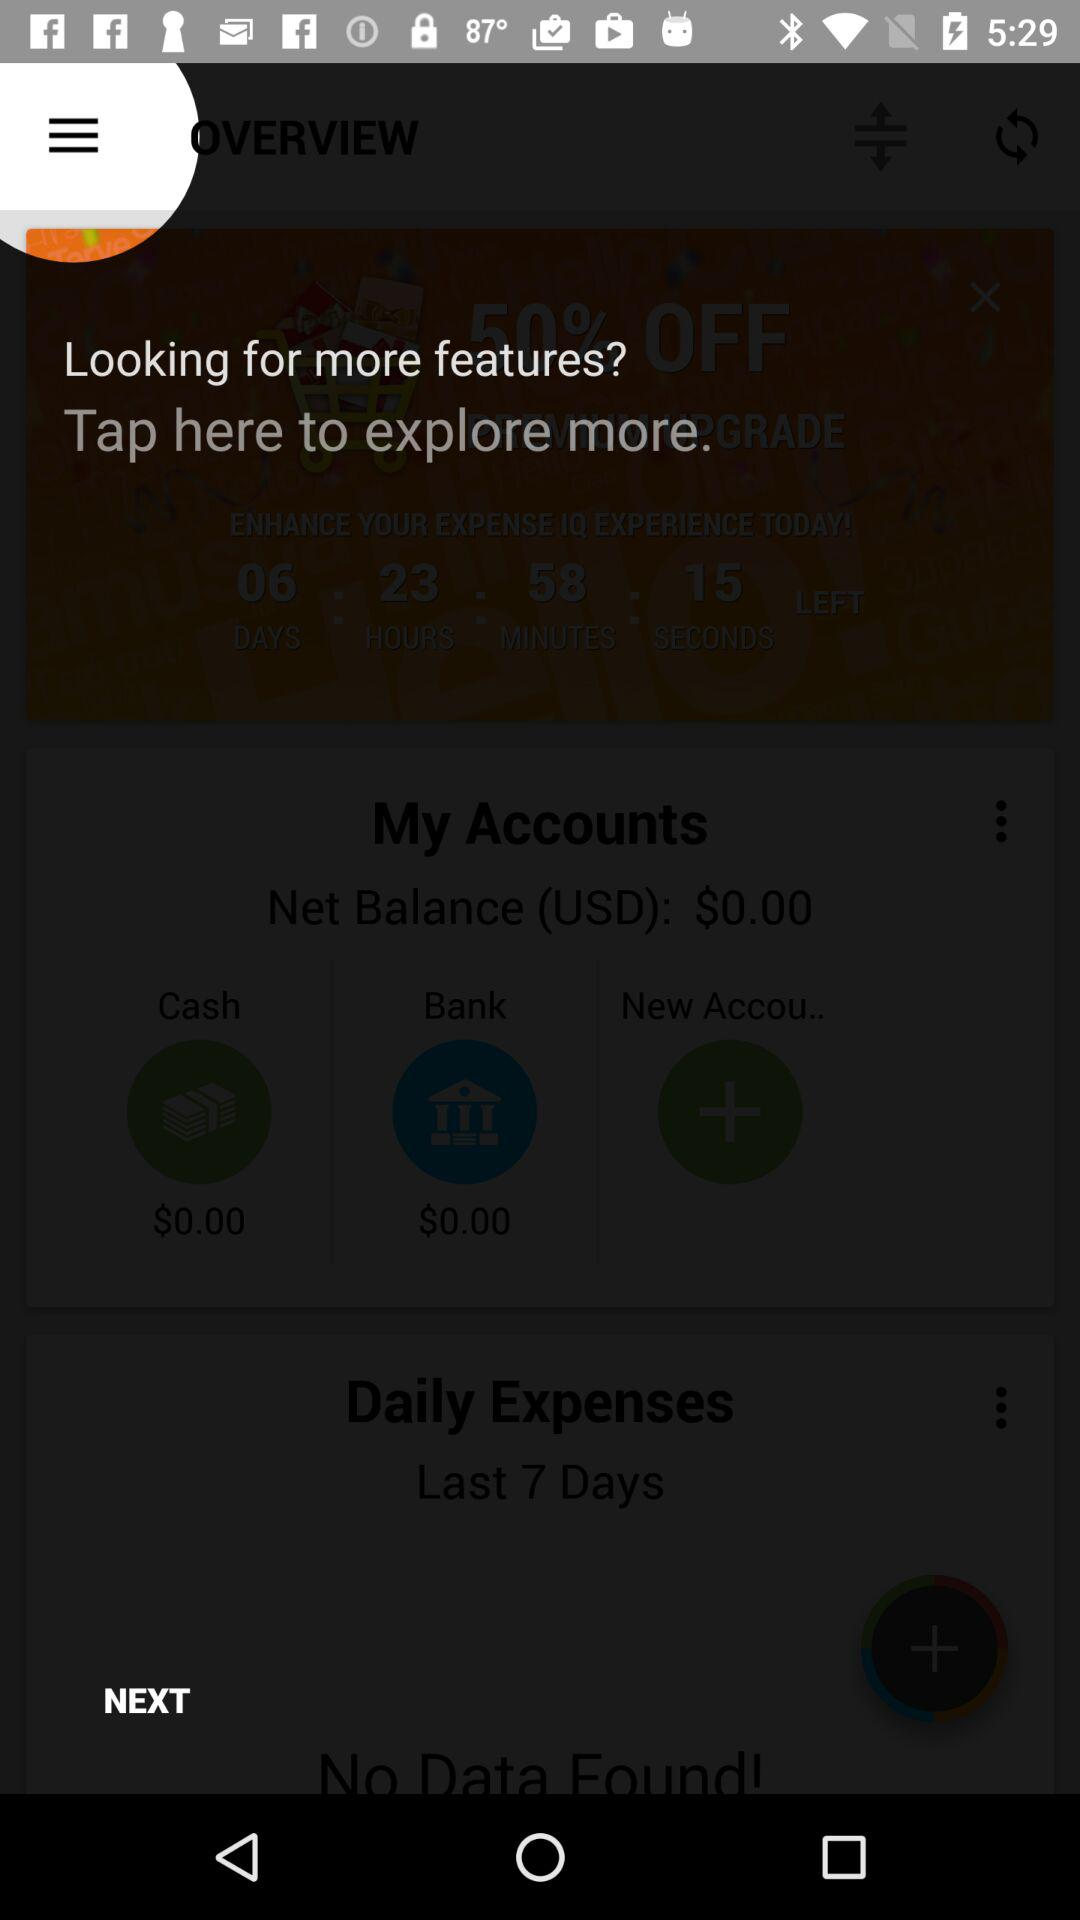What is the net balance in my account? The net balance in your account is $0. 